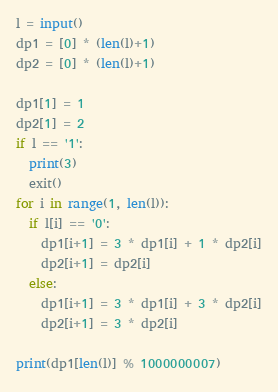Convert code to text. <code><loc_0><loc_0><loc_500><loc_500><_Python_>l = input()
dp1 = [0] * (len(l)+1)
dp2 = [0] * (len(l)+1)

dp1[1] = 1
dp2[1] = 2
if l == '1':
  print(3)
  exit()
for i in range(1, len(l)):
  if l[i] == '0':
  	dp1[i+1] = 3 * dp1[i] + 1 * dp2[i]
  	dp2[i+1] = dp2[i]
  else:
    dp1[i+1] = 3 * dp1[i] + 3 * dp2[i]
    dp2[i+1] = 3 * dp2[i]

print(dp1[len(l)] % 1000000007)</code> 